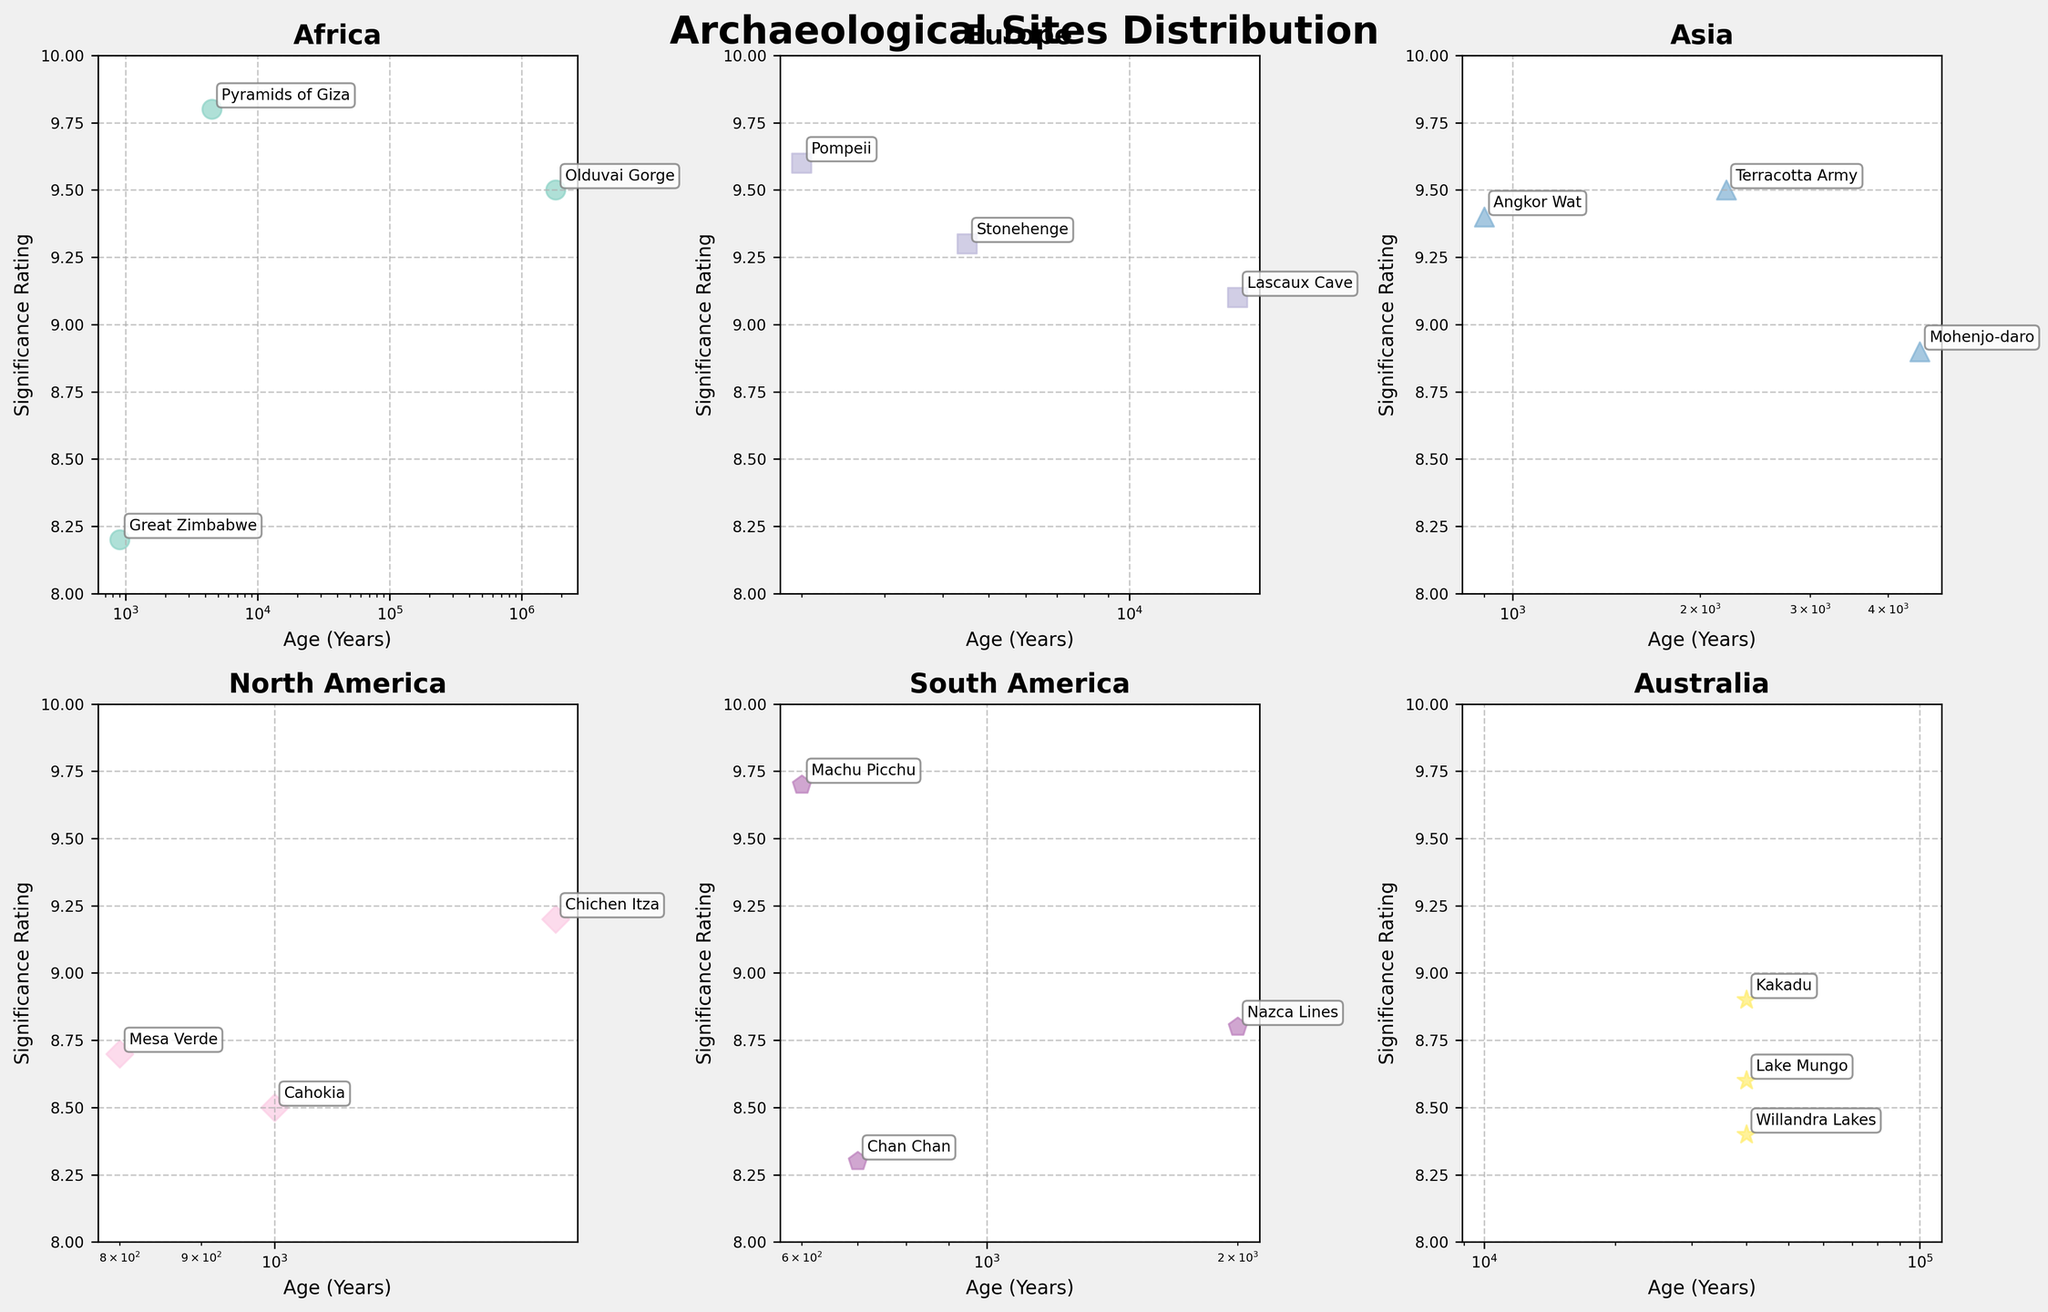What's the title of this figure? The title is positioned at the top and clearly states the main topic of the figure, indicating the distribution of archaeological sites.
Answer: Archaeological Sites Distribution How many continents are represented in the figure? The figure shows subplots for different continents, and visually there are six subplots. This indicates six continents.
Answer: 6 Which continent has the archaeological site with the highest significance rating? By observing the significance ratings on the y-axis, the pyramids of Giza in Africa have the highest rating of 9.8.
Answer: Africa What is the age range of the sites in Europe? In the Europe subplot, the x-axis represents the ages of sites. The ages range from around 2,000 years (Pompeii) to approximately 17,000 years (Lascaux Cave).
Answer: 2,000 - 17,000 years Which site in South America has a significance rating of 9.7? In the subplot for South America, the site with a rating of 9.7 on the y-axis is annotated as Machu Picchu.
Answer: Machu Picchu How many archaeological sites are plotted for North America? By counting the data points in the subplot for North America, we see there are three archaeological sites represented.
Answer: 3 Is there any site in the figure with an age exactly 900 years? Cross-referencing all subplots with the x-axis for 900 years, we find two sites: Great Zimbabwe in Africa and Angkor Wat in Asia.
Answer: 2 sites (Great Zimbabwe, Angkor Wat) Which continent has archaeological sites within the age range of 40,000 years? Observing the x-axis of different subplots, Australia shows sites like Lake Mungo, Kakadu, and Willandra Lakes, all with ages around 40,000 years.
Answer: Australia Which continent has the widest age range of archaeological sites? Comparing the ranges on the x-axis for all subplots, Australia has the widest range from around 40,000 years to 40,000 years, followed by Europe ranging from 2,000 to 17,000 years.
Answer: Australia How does the significance rating of Stonehenge compare to the Pyramids of Giza? Stonehenge in Europe has a significance rating of 9.3, while the Pyramids of Giza in Africa have a rating of 9.8. Therefore, the significance rating of Stonehenge is lower.
Answer: Lower 